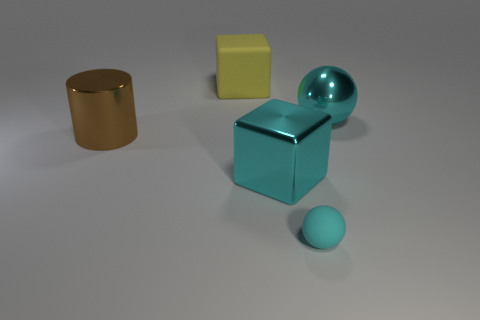Add 4 large cyan rubber objects. How many objects exist? 9 Add 1 metallic objects. How many metallic objects exist? 4 Subtract 0 blue spheres. How many objects are left? 5 Subtract all cylinders. How many objects are left? 4 Subtract all large balls. Subtract all big yellow cubes. How many objects are left? 3 Add 1 cyan matte objects. How many cyan matte objects are left? 2 